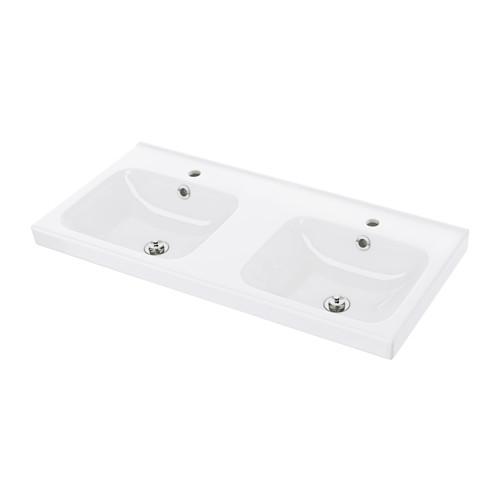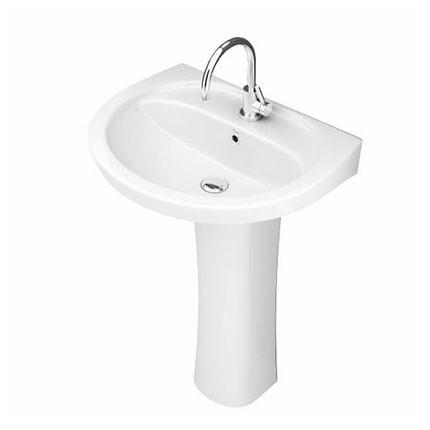The first image is the image on the left, the second image is the image on the right. For the images shown, is this caption "One image shows a rectangular, nonpedestal sink with an integrated flat counter." true? Answer yes or no. Yes. 